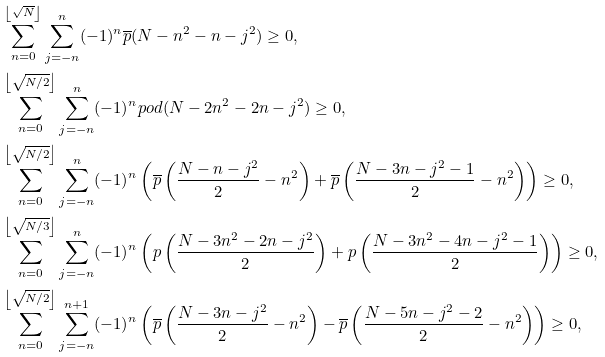<formula> <loc_0><loc_0><loc_500><loc_500>& \sum _ { n = 0 } ^ { \left \lfloor \sqrt { N } \right \rfloor } \sum _ { j = - n } ^ { n } ( - 1 ) ^ { n } \overline { p } ( N - n ^ { 2 } - n - j ^ { 2 } ) \geq 0 , \\ & \sum _ { n = 0 } ^ { \left \lfloor \sqrt { N / 2 } \right \rfloor } \sum _ { j = - n } ^ { n } ( - 1 ) ^ { n } p o d ( N - 2 n ^ { 2 } - 2 n - j ^ { 2 } ) \geq 0 , \\ & \sum _ { n = 0 } ^ { \left \lfloor \sqrt { N / 2 } \right \rfloor } \sum _ { j = - n } ^ { n } ( - 1 ) ^ { n } \left ( \overline { p } \left ( \frac { N - n - j ^ { 2 } } { 2 } - n ^ { 2 } \right ) + \overline { p } \left ( \frac { N - 3 n - j ^ { 2 } - 1 } { 2 } - n ^ { 2 } \right ) \right ) \geq 0 , \\ & \sum _ { n = 0 } ^ { \left \lfloor \sqrt { N / 3 } \right \rfloor } \sum _ { j = - n } ^ { n } ( - 1 ) ^ { n } \left ( p \left ( \frac { N - 3 n ^ { 2 } - 2 n - j ^ { 2 } } { 2 } \right ) + p \left ( \frac { N - 3 n ^ { 2 } - 4 n - j ^ { 2 } - 1 } { 2 } \right ) \right ) \geq 0 , \\ & \sum _ { n = 0 } ^ { \left \lfloor \sqrt { N / 2 } \right \rfloor } \sum _ { j = - n } ^ { n + 1 } ( - 1 ) ^ { n } \left ( \overline { p } \left ( \frac { N - 3 n - j ^ { 2 } } { 2 } - n ^ { 2 } \right ) - \overline { p } \left ( \frac { N - 5 n - j ^ { 2 } - 2 } { 2 } - n ^ { 2 } \right ) \right ) \geq 0 ,</formula> 